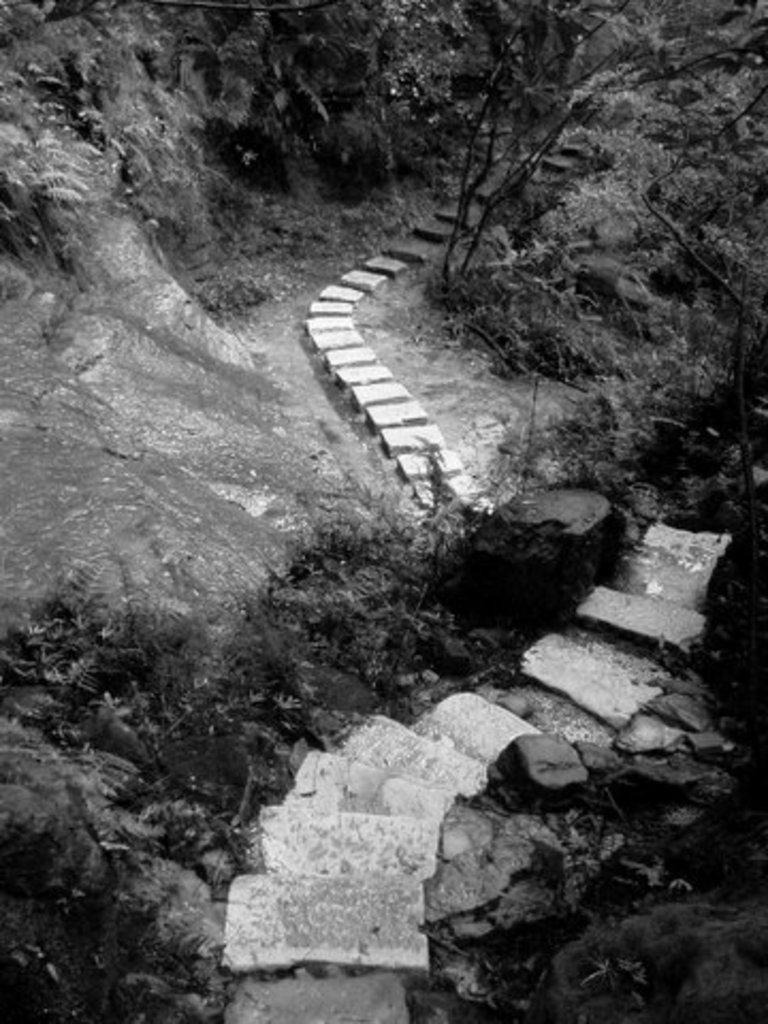Can you describe this image briefly? In this picture we can see steps, stones and in the background we can see trees. 